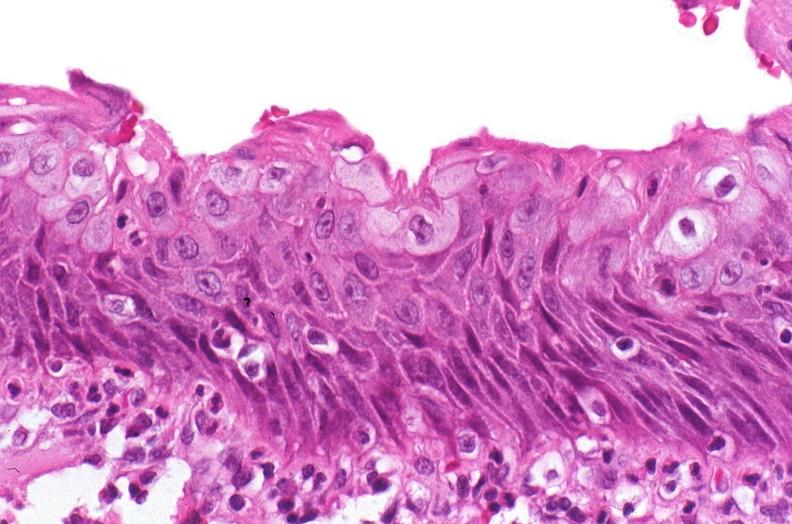what is present?
Answer the question using a single word or phrase. Urinary 